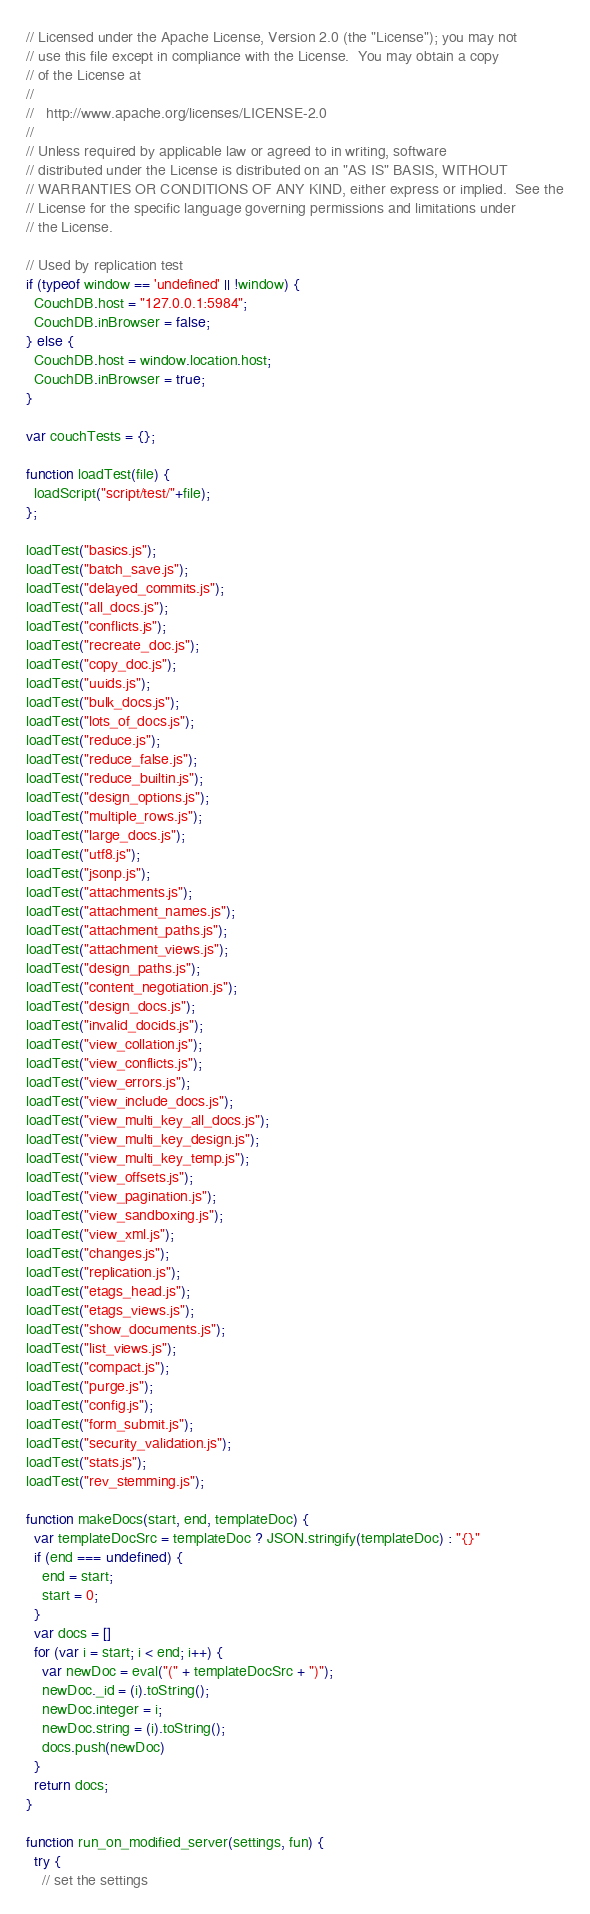Convert code to text. <code><loc_0><loc_0><loc_500><loc_500><_JavaScript_>// Licensed under the Apache License, Version 2.0 (the "License"); you may not
// use this file except in compliance with the License.  You may obtain a copy
// of the License at
//
//   http://www.apache.org/licenses/LICENSE-2.0
//
// Unless required by applicable law or agreed to in writing, software
// distributed under the License is distributed on an "AS IS" BASIS, WITHOUT
// WARRANTIES OR CONDITIONS OF ANY KIND, either express or implied.  See the
// License for the specific language governing permissions and limitations under
// the License.

// Used by replication test
if (typeof window == 'undefined' || !window) {
  CouchDB.host = "127.0.0.1:5984";
  CouchDB.inBrowser = false;
} else {
  CouchDB.host = window.location.host;
  CouchDB.inBrowser = true;
}

var couchTests = {};

function loadTest(file) {
  loadScript("script/test/"+file);
};

loadTest("basics.js");
loadTest("batch_save.js");
loadTest("delayed_commits.js");
loadTest("all_docs.js");
loadTest("conflicts.js");
loadTest("recreate_doc.js");
loadTest("copy_doc.js");
loadTest("uuids.js");
loadTest("bulk_docs.js");
loadTest("lots_of_docs.js");
loadTest("reduce.js");
loadTest("reduce_false.js");
loadTest("reduce_builtin.js");
loadTest("design_options.js");
loadTest("multiple_rows.js");
loadTest("large_docs.js");
loadTest("utf8.js");
loadTest("jsonp.js");
loadTest("attachments.js");
loadTest("attachment_names.js");
loadTest("attachment_paths.js");
loadTest("attachment_views.js");
loadTest("design_paths.js");
loadTest("content_negotiation.js");
loadTest("design_docs.js");
loadTest("invalid_docids.js");
loadTest("view_collation.js");
loadTest("view_conflicts.js");
loadTest("view_errors.js");
loadTest("view_include_docs.js");
loadTest("view_multi_key_all_docs.js");
loadTest("view_multi_key_design.js");
loadTest("view_multi_key_temp.js");
loadTest("view_offsets.js");
loadTest("view_pagination.js");
loadTest("view_sandboxing.js");
loadTest("view_xml.js");
loadTest("changes.js");
loadTest("replication.js");
loadTest("etags_head.js");
loadTest("etags_views.js");
loadTest("show_documents.js");
loadTest("list_views.js");
loadTest("compact.js");
loadTest("purge.js");
loadTest("config.js");
loadTest("form_submit.js");
loadTest("security_validation.js");
loadTest("stats.js");
loadTest("rev_stemming.js");

function makeDocs(start, end, templateDoc) {
  var templateDocSrc = templateDoc ? JSON.stringify(templateDoc) : "{}"
  if (end === undefined) {
    end = start;
    start = 0;
  }
  var docs = []
  for (var i = start; i < end; i++) {
    var newDoc = eval("(" + templateDocSrc + ")");
    newDoc._id = (i).toString();
    newDoc.integer = i;
    newDoc.string = (i).toString();
    docs.push(newDoc)
  }
  return docs;
}

function run_on_modified_server(settings, fun) {
  try {
    // set the settings</code> 